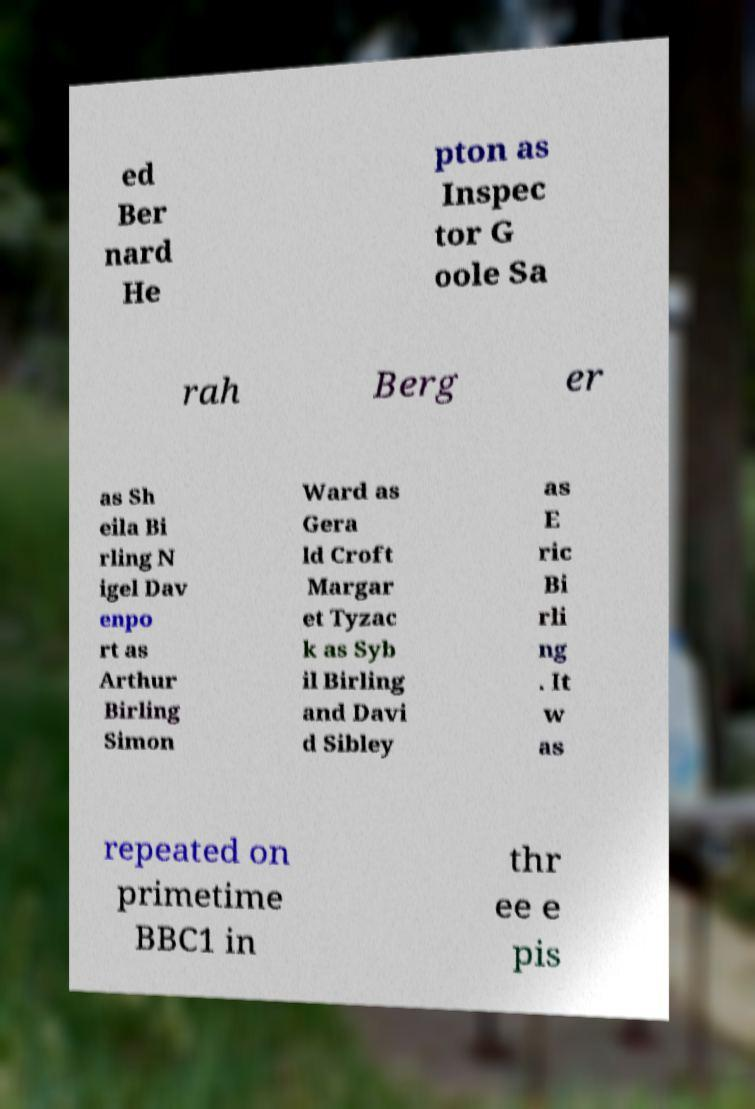What messages or text are displayed in this image? I need them in a readable, typed format. ed Ber nard He pton as Inspec tor G oole Sa rah Berg er as Sh eila Bi rling N igel Dav enpo rt as Arthur Birling Simon Ward as Gera ld Croft Margar et Tyzac k as Syb il Birling and Davi d Sibley as E ric Bi rli ng . It w as repeated on primetime BBC1 in thr ee e pis 